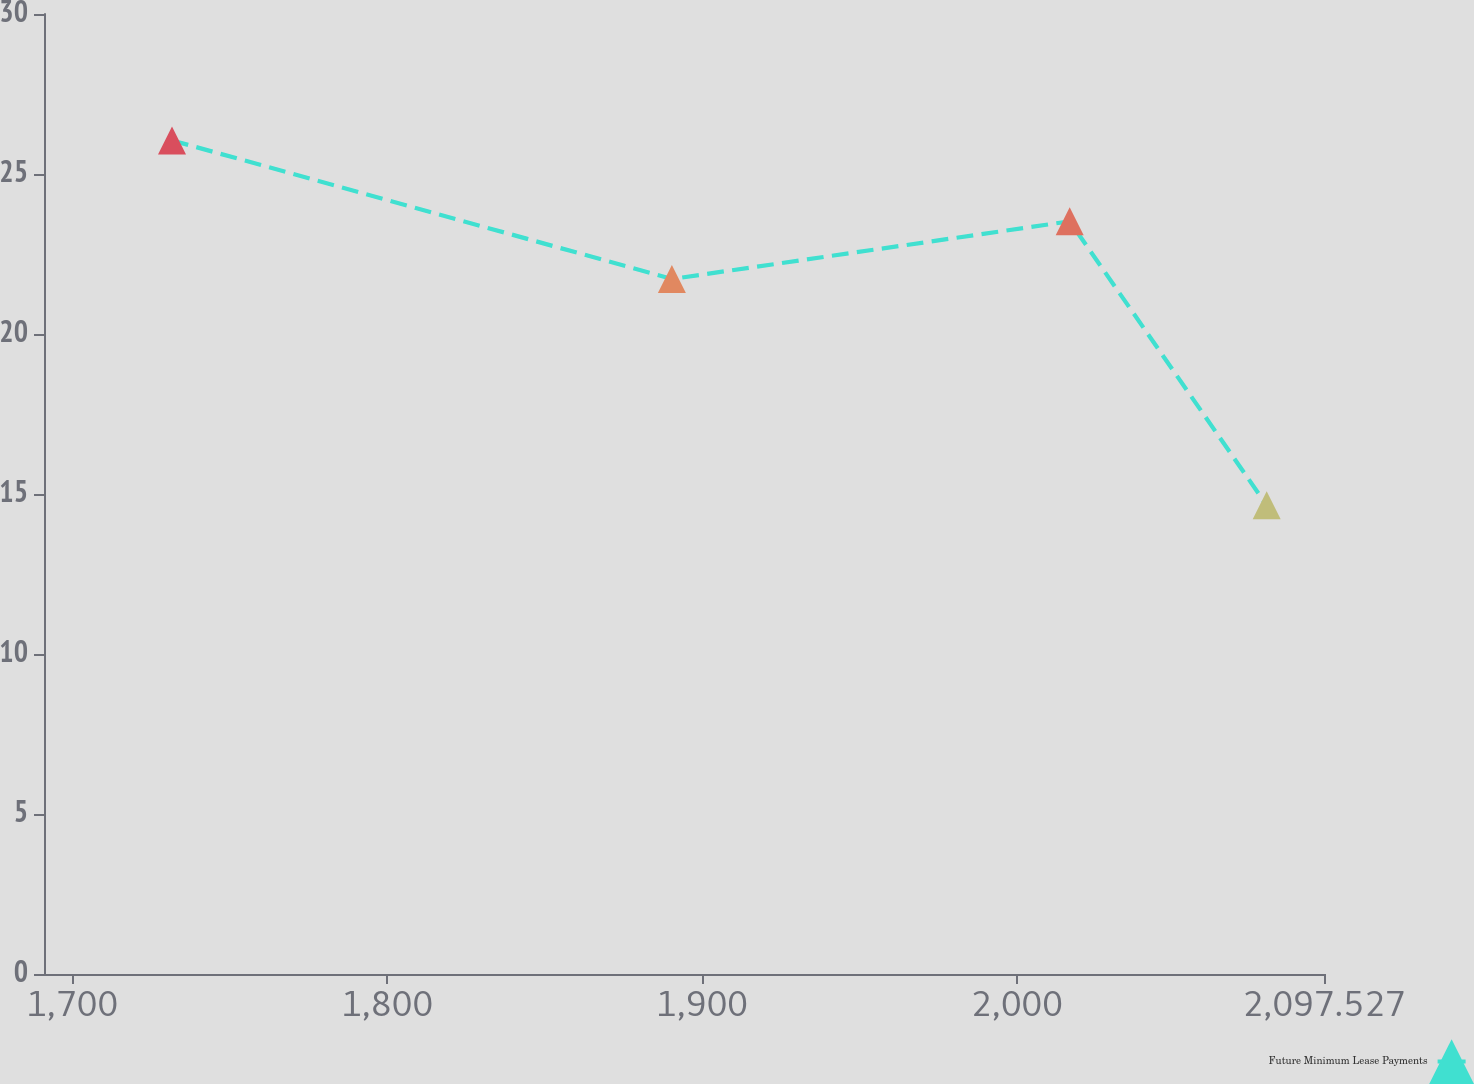Convert chart. <chart><loc_0><loc_0><loc_500><loc_500><line_chart><ecel><fcel>Future Minimum Lease Payments<nl><fcel>1731.74<fcel>26.05<nl><fcel>1890.46<fcel>21.72<nl><fcel>2016.78<fcel>23.52<nl><fcel>2079.32<fcel>14.65<nl><fcel>2138.17<fcel>8.09<nl></chart> 